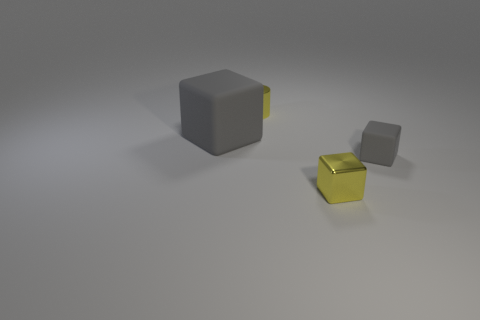Subtract all green cubes. Subtract all blue cylinders. How many cubes are left? 3 Add 3 small gray matte objects. How many objects exist? 7 Subtract all cubes. How many objects are left? 1 Add 1 yellow metallic objects. How many yellow metallic objects are left? 3 Add 3 purple metal things. How many purple metal things exist? 3 Subtract 0 cyan cylinders. How many objects are left? 4 Subtract all tiny blue rubber things. Subtract all big matte blocks. How many objects are left? 3 